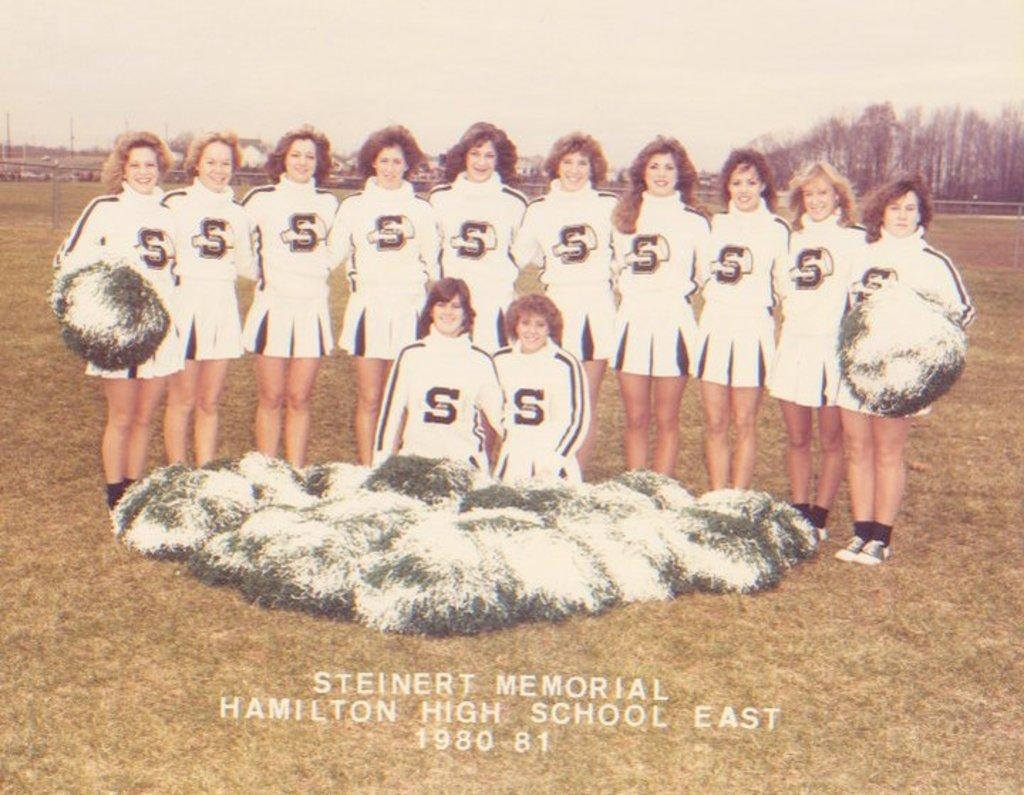Provide a one-sentence caption for the provided image. Steinert Memorial 1980-81 cheerleaders posed for a picture. 